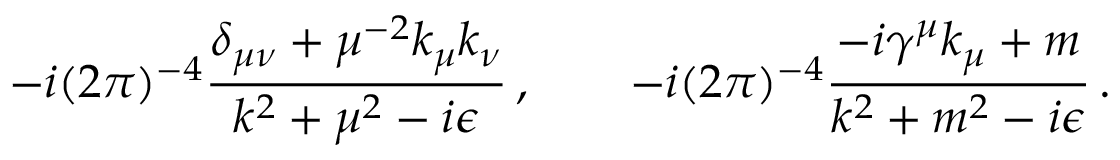Convert formula to latex. <formula><loc_0><loc_0><loc_500><loc_500>- i ( 2 \pi ) ^ { - 4 } { \frac { \delta _ { \mu \nu } + \mu ^ { - 2 } k _ { \mu } k _ { \nu } } { k ^ { 2 } + \mu ^ { 2 } - i \epsilon } } \, , \quad - i ( 2 \pi ) ^ { - 4 } { \frac { - i \gamma ^ { \mu } k _ { \mu } + m } { k ^ { 2 } + m ^ { 2 } - i \epsilon } } \, .</formula> 